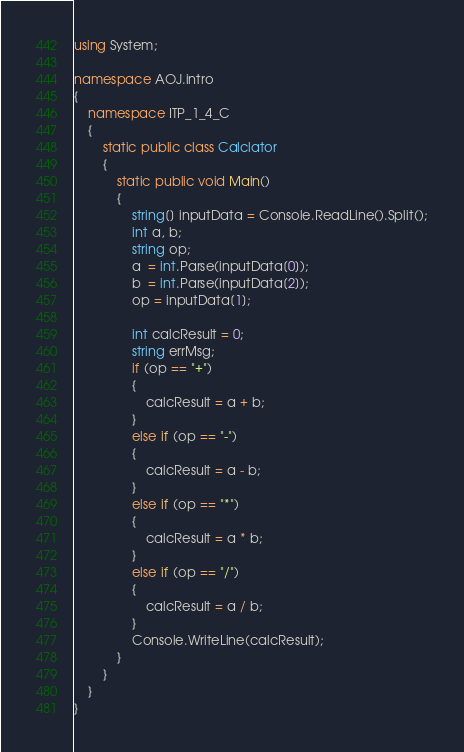Convert code to text. <code><loc_0><loc_0><loc_500><loc_500><_C#_>using System;

namespace AOJ.intro
{
    namespace ITP_1_4_C
    {
        static public class Calclator
        {
            static public void Main()
            {
                string[] inputData = Console.ReadLine().Split();
                int a, b;
                string op;
                a  = int.Parse(inputData[0]);
                b  = int.Parse(inputData[2]);
                op = inputData[1];

                int calcResult = 0;
                string errMsg;
                if (op == "+")
                {
                    calcResult = a + b;
                }
                else if (op == "-")
                {
                    calcResult = a - b;
                }
                else if (op == "*")
                {
                    calcResult = a * b;
                }
                else if (op == "/")
                {
                    calcResult = a / b;
                }
                Console.WriteLine(calcResult);
            }
        }
    }
}
</code> 